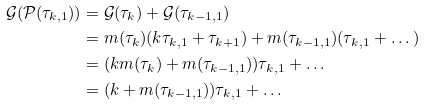<formula> <loc_0><loc_0><loc_500><loc_500>\mathcal { G } ( \mathcal { P } ( \tau _ { k , 1 } ) ) & = \mathcal { G } ( \tau _ { k } ) + \mathcal { G } ( \tau _ { k - 1 , 1 } ) \\ & = m ( \tau _ { k } ) ( k \tau _ { k , 1 } + \tau _ { k + 1 } ) + m ( \tau _ { k - 1 , 1 } ) ( \tau _ { k , 1 } + \dots ) \\ & = ( k m ( \tau _ { k } ) + m ( \tau _ { k - 1 , 1 } ) ) \tau _ { k , 1 } + \dots \\ & = ( k + m ( \tau _ { k - 1 , 1 } ) ) \tau _ { k , 1 } + \dots</formula> 